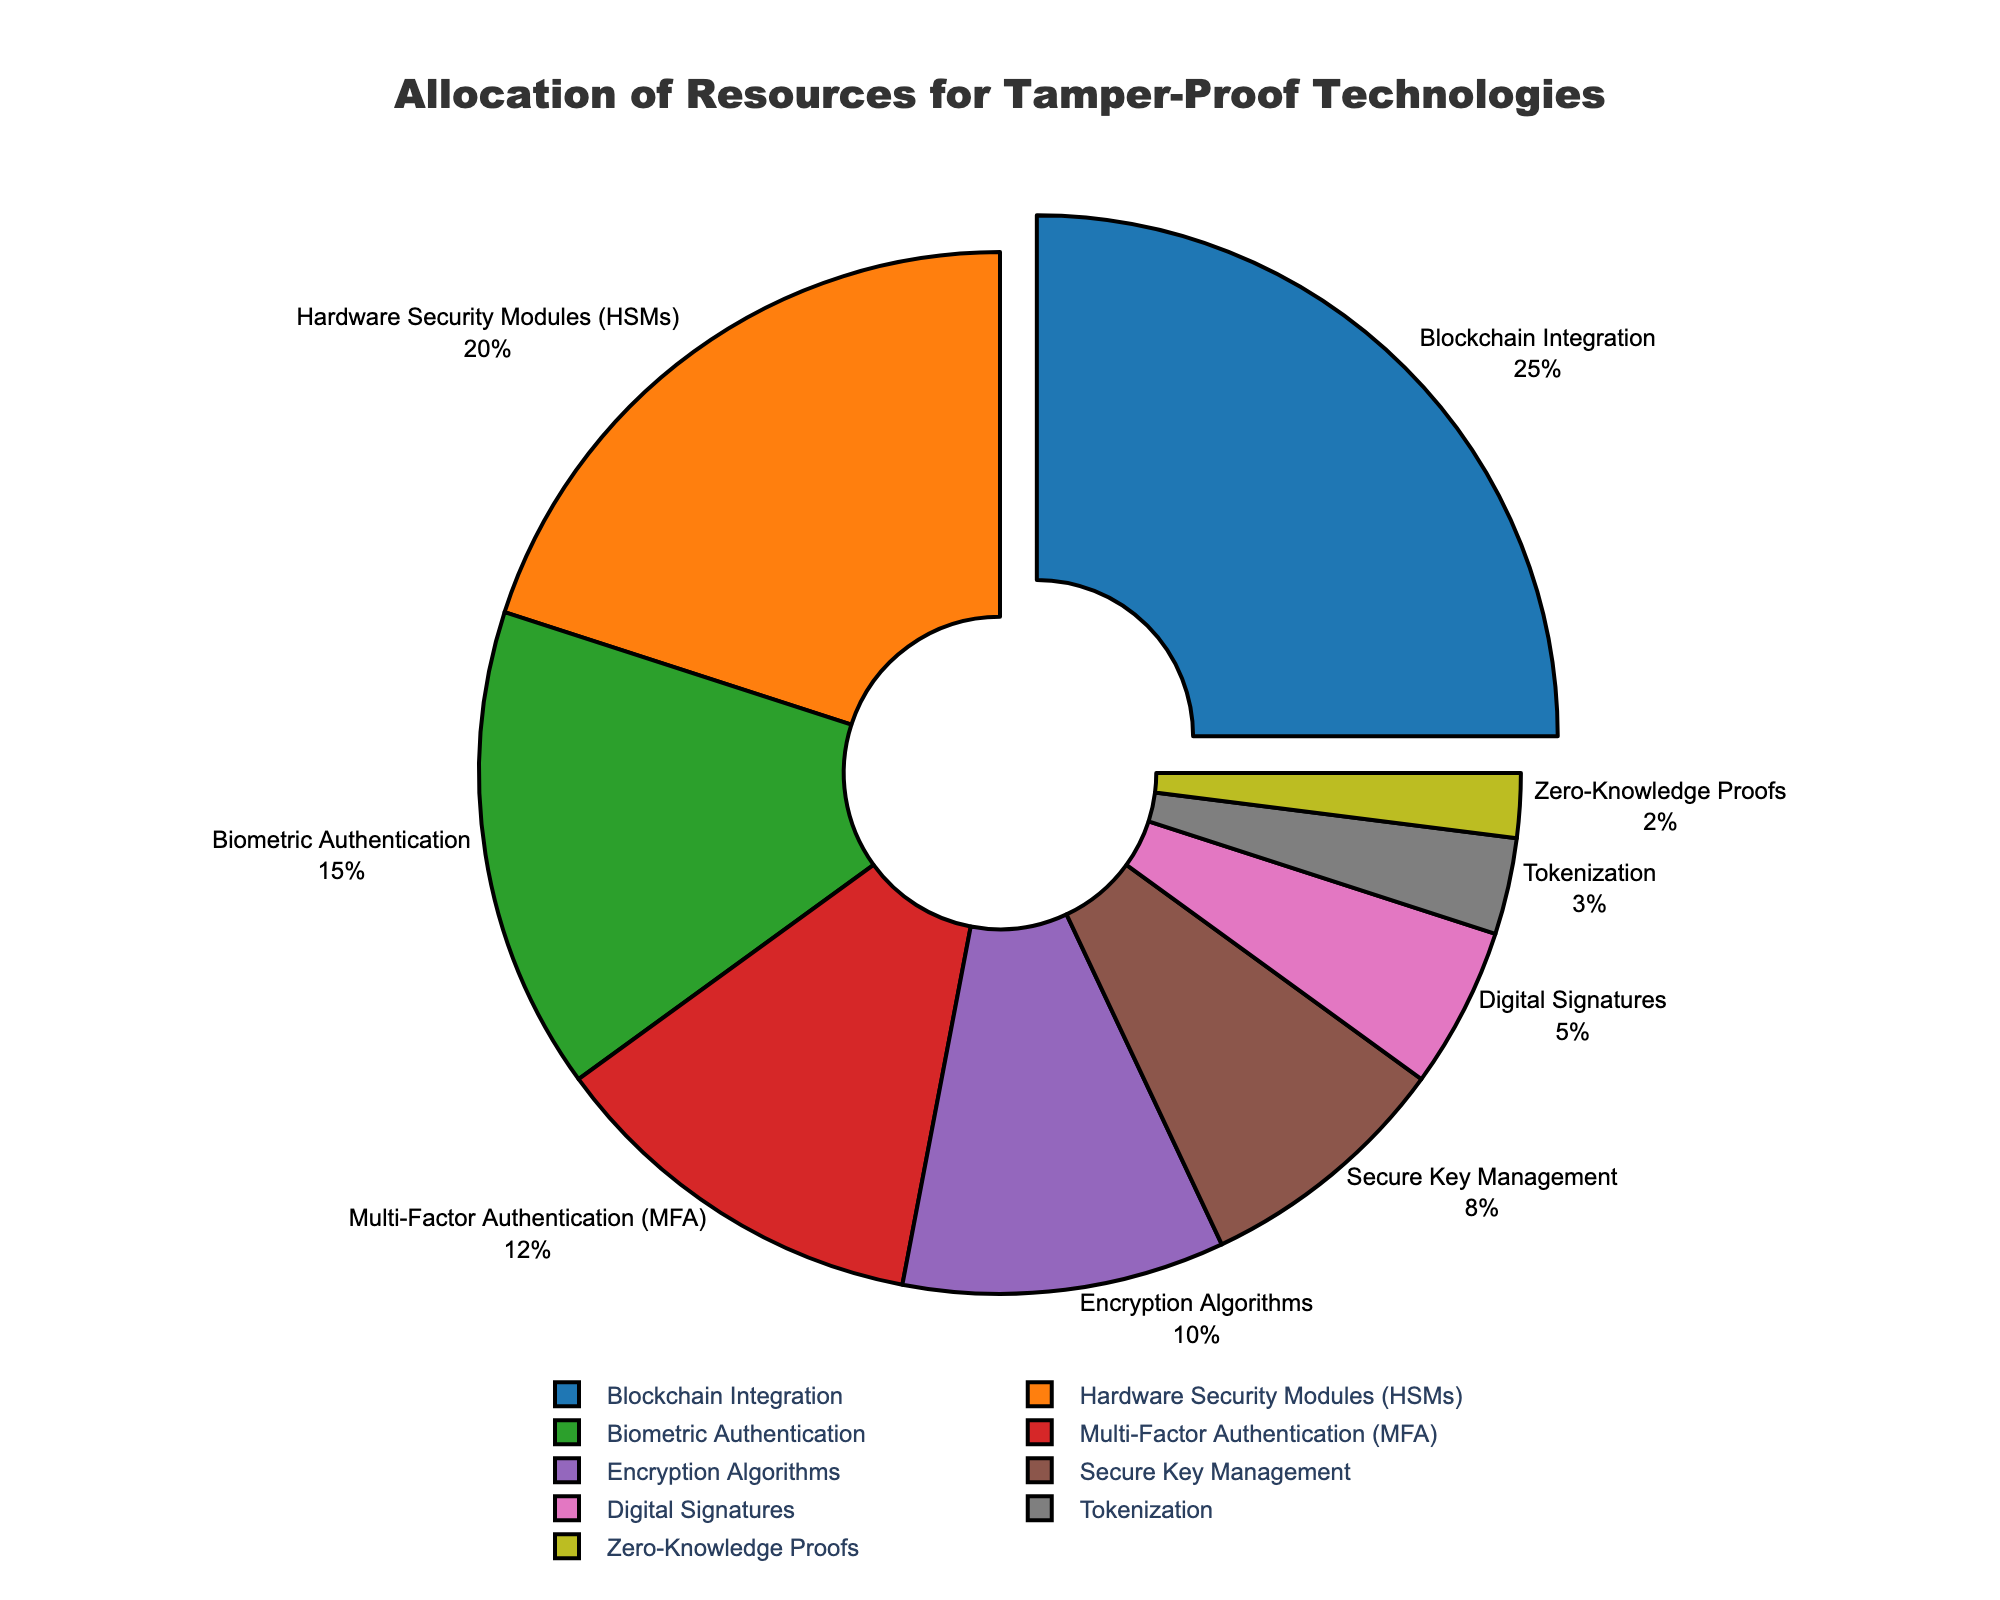What percentage of the resources is allocated to Blockchain Integration? Blockchain Integration accounts for 25% of the resources, as indicated by the segment labeled "Blockchain Integration" in the pie chart.
Answer: 25% What is the total percentage of resources allocated to Biometric Authentication and MFA combined? Biometric Authentication is 15%, and MFA is 12%. Adding these two values gives 15% + 12% = 27%.
Answer: 27% Which technology has the smallest allocation, and what is its percentage? Zero-Knowledge Proofs have the smallest allocation with 2%, as indicated by the smallest segment in the pie chart.
Answer: Zero-Knowledge Proofs, 2% How much more percentage of resources is allocated to Hardware Security Modules (HSMs) compared to Digital Signatures? HSMs have 20% allocation, and Digital Signatures have 5%. So, the difference is 20% - 5% = 15%.
Answer: 15% Which technology has the largest allocation, and how does this compare to the technology with the second-largest allocation? Blockchain Integration has the largest allocation at 25%. The second-largest allocation is for HSMs at 20%. The difference is 25% - 20% = 5%.
Answer: Blockchain Integration, 5% What are the combined resource allocations for Encryption Algorithms, Secure Key Management, and Digital Signatures? The allocations are 10% for Encryption Algorithms, 8% for Secure Key Management, and 5% for Digital Signatures. Combined, this gives 10% + 8% + 5% = 23%.
Answer: 23% Which segment is visually pulled out from the pie chart, and why do you think this is done? The Blockchain Integration segment is visually pulled out, likely to highlight that it has the largest percentage of resource allocation.
Answer: Blockchain Integration, to highlight its significance How does the allocation for Tokenization compare to the allocation for Biometric Authentication? Tokenization has an allocation of 3%, while Biometric Authentication has 15%. Biometric Authentication is 15% - 3% = 12% higher than Tokenization.
Answer: 12% higher What is the total percentage of resources allocated to technologies with allocations less than 10%? Allocations less than 10% are Secure Key Management (8%), Digital Signatures (5%), Tokenization (3%), and Zero-Knowledge Proofs (2%). Adding these gives 8% + 5% + 3% + 2% = 18%.
Answer: 18% 